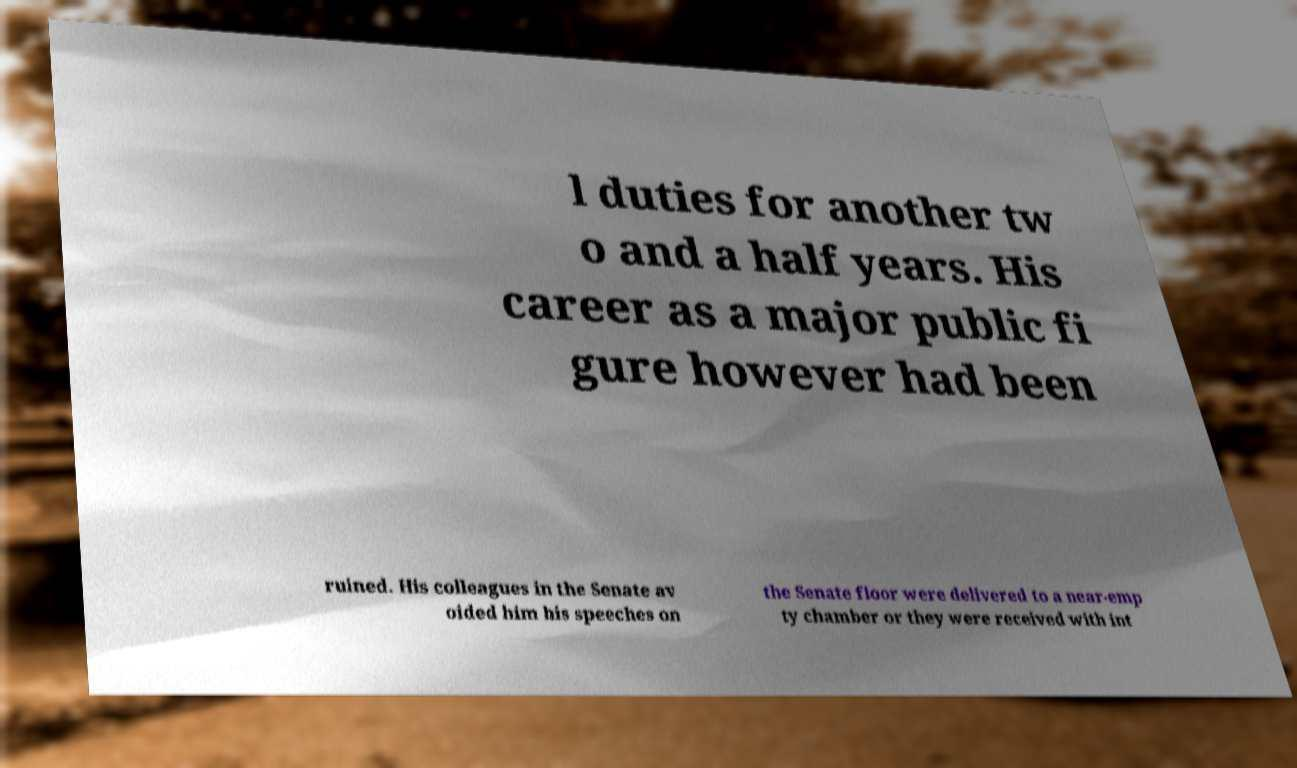For documentation purposes, I need the text within this image transcribed. Could you provide that? l duties for another tw o and a half years. His career as a major public fi gure however had been ruined. His colleagues in the Senate av oided him his speeches on the Senate floor were delivered to a near-emp ty chamber or they were received with int 